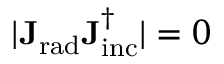<formula> <loc_0><loc_0><loc_500><loc_500>| J _ { r a d } J _ { i n c } ^ { \dagger } | = 0</formula> 